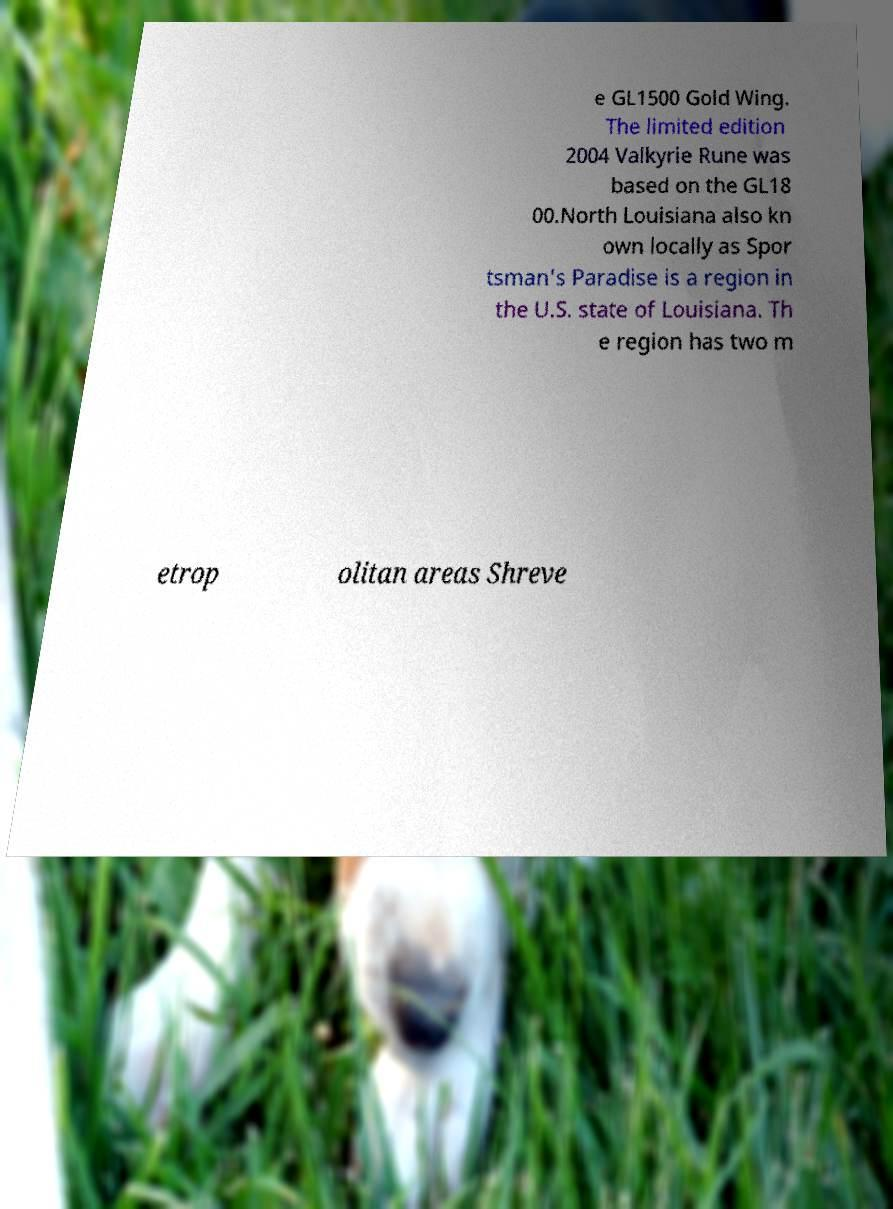What messages or text are displayed in this image? I need them in a readable, typed format. e GL1500 Gold Wing. The limited edition 2004 Valkyrie Rune was based on the GL18 00.North Louisiana also kn own locally as Spor tsman's Paradise is a region in the U.S. state of Louisiana. Th e region has two m etrop olitan areas Shreve 